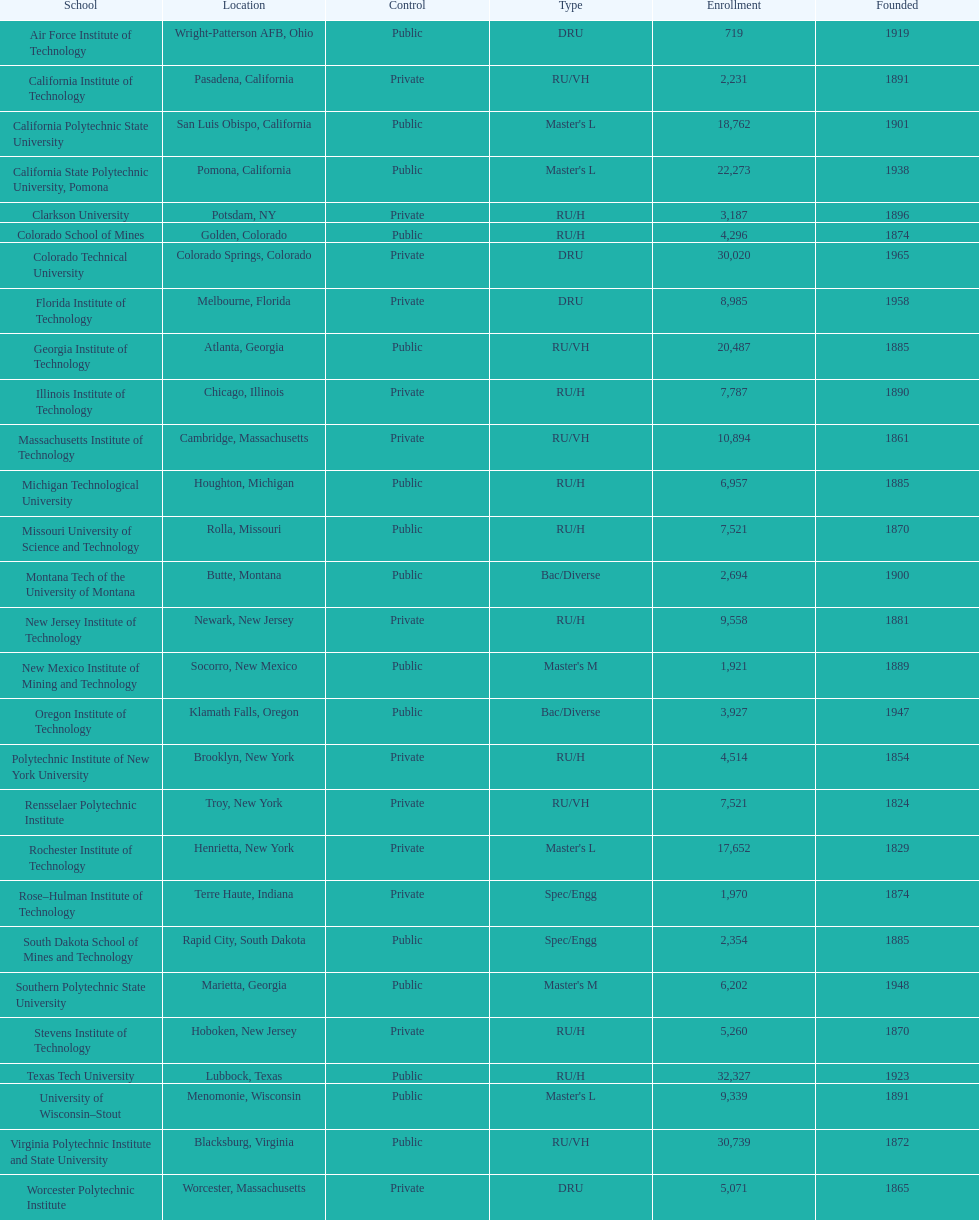Which of the universities was founded first? Rensselaer Polytechnic Institute. 